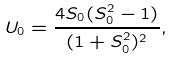<formula> <loc_0><loc_0><loc_500><loc_500>U _ { 0 } = \frac { 4 S _ { 0 } ( S _ { 0 } ^ { 2 } - 1 ) } { ( 1 + S _ { 0 } ^ { 2 } ) ^ { 2 } } ,</formula> 